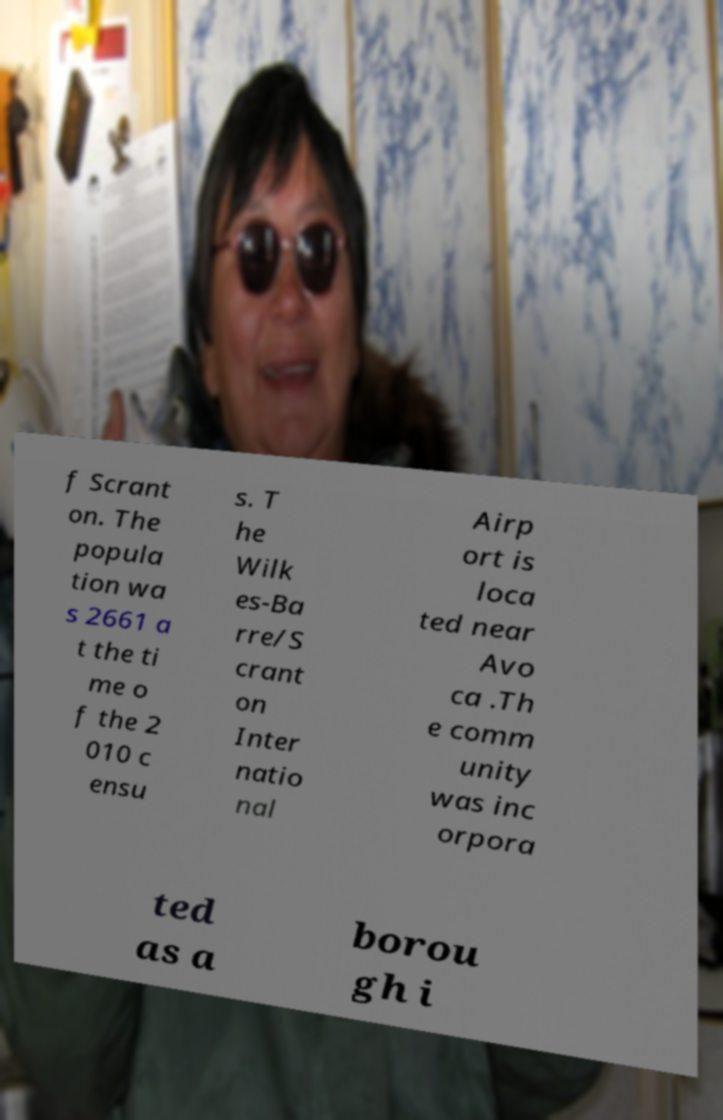Could you extract and type out the text from this image? f Scrant on. The popula tion wa s 2661 a t the ti me o f the 2 010 c ensu s. T he Wilk es-Ba rre/S crant on Inter natio nal Airp ort is loca ted near Avo ca .Th e comm unity was inc orpora ted as a borou gh i 